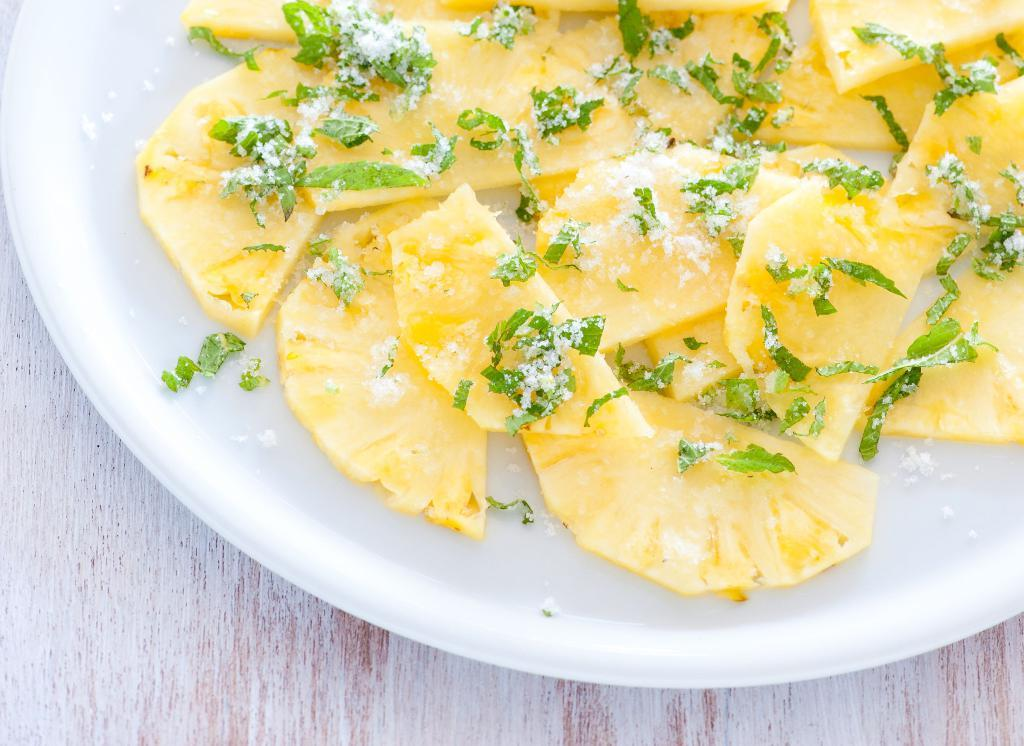What object is present on the table in the image? There is a plate in the image. What is on the plate? There is a food item on the plate. Where is the plate located? The plate is on a table. What substance is being used to measure the time in the image? There is no substance being used to measure time in the image. Is there any land visible in the image? The image does not depict any land; it only features a plate with a food item on a table. 